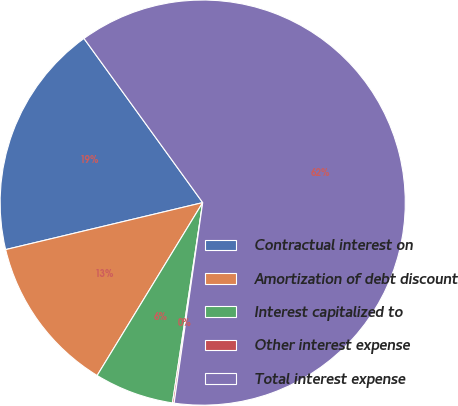Convert chart. <chart><loc_0><loc_0><loc_500><loc_500><pie_chart><fcel>Contractual interest on<fcel>Amortization of debt discount<fcel>Interest capitalized to<fcel>Other interest expense<fcel>Total interest expense<nl><fcel>18.76%<fcel>12.55%<fcel>6.34%<fcel>0.13%<fcel>62.22%<nl></chart> 